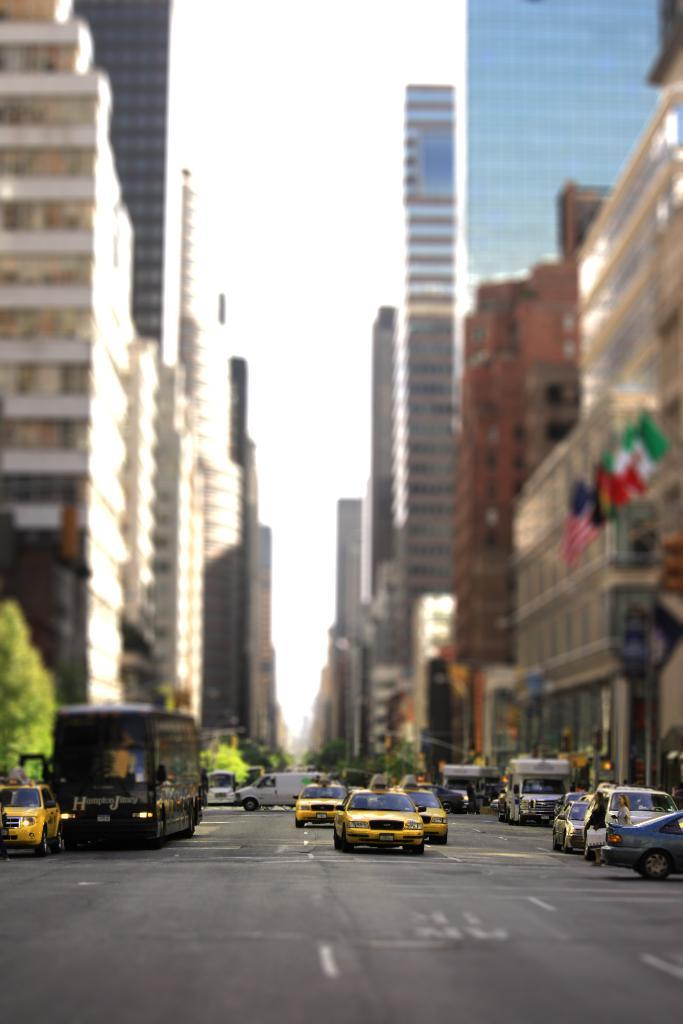What is the main subject of the image? The image shows a view of a street. What structures can be seen in the street? There are buildings in the street. What can be seen in the sky in the image? The sky is visible in the image. What decorative elements are present in the street? There are flags in the street. What type of vegetation is present in the street? Trees and bushes are visible in the street. What type of transportation can be seen in the street? Motor vehicles are on the road in the street. What type of twig is being used as a house in the image? There is no twig being used as a house in the image; the image shows a view of a street with buildings. What type of land is visible in the image? The image shows a view of a street, so it is not possible to determine the type of land from the image alone. 